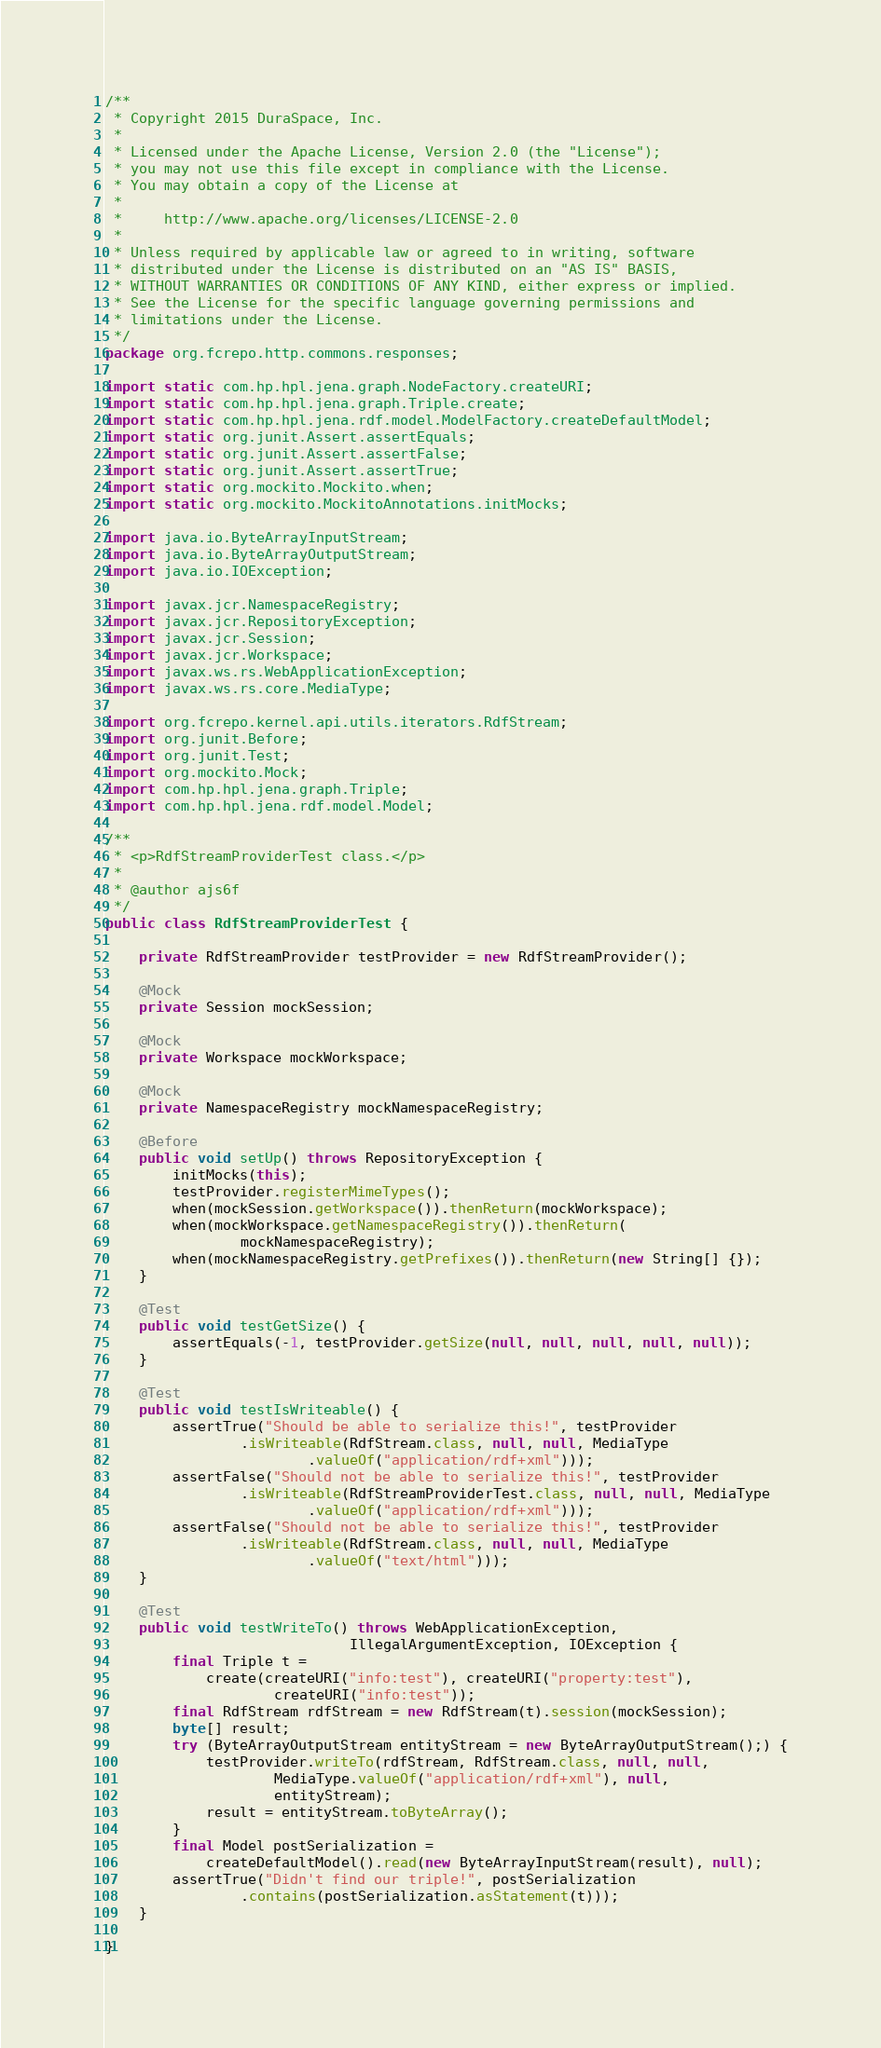<code> <loc_0><loc_0><loc_500><loc_500><_Java_>/**
 * Copyright 2015 DuraSpace, Inc.
 *
 * Licensed under the Apache License, Version 2.0 (the "License");
 * you may not use this file except in compliance with the License.
 * You may obtain a copy of the License at
 *
 *     http://www.apache.org/licenses/LICENSE-2.0
 *
 * Unless required by applicable law or agreed to in writing, software
 * distributed under the License is distributed on an "AS IS" BASIS,
 * WITHOUT WARRANTIES OR CONDITIONS OF ANY KIND, either express or implied.
 * See the License for the specific language governing permissions and
 * limitations under the License.
 */
package org.fcrepo.http.commons.responses;

import static com.hp.hpl.jena.graph.NodeFactory.createURI;
import static com.hp.hpl.jena.graph.Triple.create;
import static com.hp.hpl.jena.rdf.model.ModelFactory.createDefaultModel;
import static org.junit.Assert.assertEquals;
import static org.junit.Assert.assertFalse;
import static org.junit.Assert.assertTrue;
import static org.mockito.Mockito.when;
import static org.mockito.MockitoAnnotations.initMocks;

import java.io.ByteArrayInputStream;
import java.io.ByteArrayOutputStream;
import java.io.IOException;

import javax.jcr.NamespaceRegistry;
import javax.jcr.RepositoryException;
import javax.jcr.Session;
import javax.jcr.Workspace;
import javax.ws.rs.WebApplicationException;
import javax.ws.rs.core.MediaType;

import org.fcrepo.kernel.api.utils.iterators.RdfStream;
import org.junit.Before;
import org.junit.Test;
import org.mockito.Mock;
import com.hp.hpl.jena.graph.Triple;
import com.hp.hpl.jena.rdf.model.Model;

/**
 * <p>RdfStreamProviderTest class.</p>
 *
 * @author ajs6f
 */
public class RdfStreamProviderTest {

    private RdfStreamProvider testProvider = new RdfStreamProvider();

    @Mock
    private Session mockSession;

    @Mock
    private Workspace mockWorkspace;

    @Mock
    private NamespaceRegistry mockNamespaceRegistry;

    @Before
    public void setUp() throws RepositoryException {
        initMocks(this);
        testProvider.registerMimeTypes();
        when(mockSession.getWorkspace()).thenReturn(mockWorkspace);
        when(mockWorkspace.getNamespaceRegistry()).thenReturn(
                mockNamespaceRegistry);
        when(mockNamespaceRegistry.getPrefixes()).thenReturn(new String[] {});
    }

    @Test
    public void testGetSize() {
        assertEquals(-1, testProvider.getSize(null, null, null, null, null));
    }

    @Test
    public void testIsWriteable() {
        assertTrue("Should be able to serialize this!", testProvider
                .isWriteable(RdfStream.class, null, null, MediaType
                        .valueOf("application/rdf+xml")));
        assertFalse("Should not be able to serialize this!", testProvider
                .isWriteable(RdfStreamProviderTest.class, null, null, MediaType
                        .valueOf("application/rdf+xml")));
        assertFalse("Should not be able to serialize this!", testProvider
                .isWriteable(RdfStream.class, null, null, MediaType
                        .valueOf("text/html")));
    }

    @Test
    public void testWriteTo() throws WebApplicationException,
                             IllegalArgumentException, IOException {
        final Triple t =
            create(createURI("info:test"), createURI("property:test"),
                    createURI("info:test"));
        final RdfStream rdfStream = new RdfStream(t).session(mockSession);
        byte[] result;
        try (ByteArrayOutputStream entityStream = new ByteArrayOutputStream();) {
            testProvider.writeTo(rdfStream, RdfStream.class, null, null,
                    MediaType.valueOf("application/rdf+xml"), null,
                    entityStream);
            result = entityStream.toByteArray();
        }
        final Model postSerialization =
            createDefaultModel().read(new ByteArrayInputStream(result), null);
        assertTrue("Didn't find our triple!", postSerialization
                .contains(postSerialization.asStatement(t)));
    }

}
</code> 